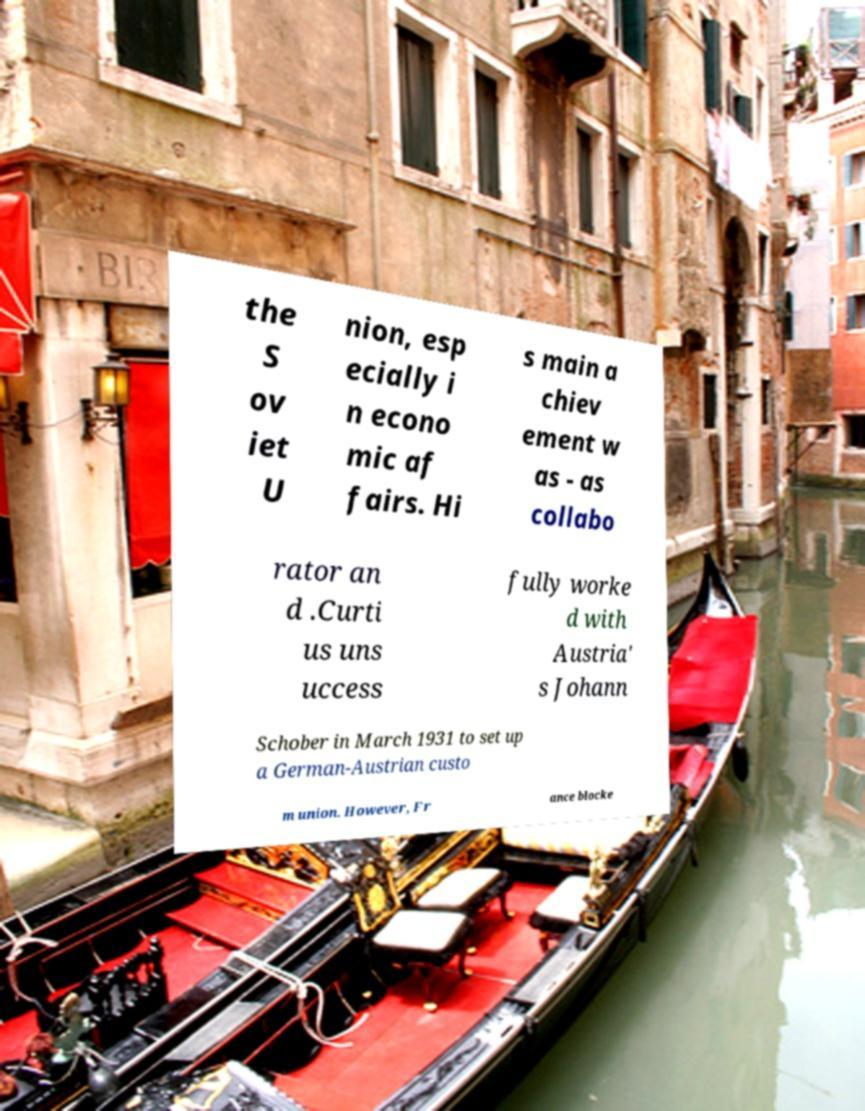Please identify and transcribe the text found in this image. the S ov iet U nion, esp ecially i n econo mic af fairs. Hi s main a chiev ement w as - as collabo rator an d .Curti us uns uccess fully worke d with Austria' s Johann Schober in March 1931 to set up a German-Austrian custo m union. However, Fr ance blocke 